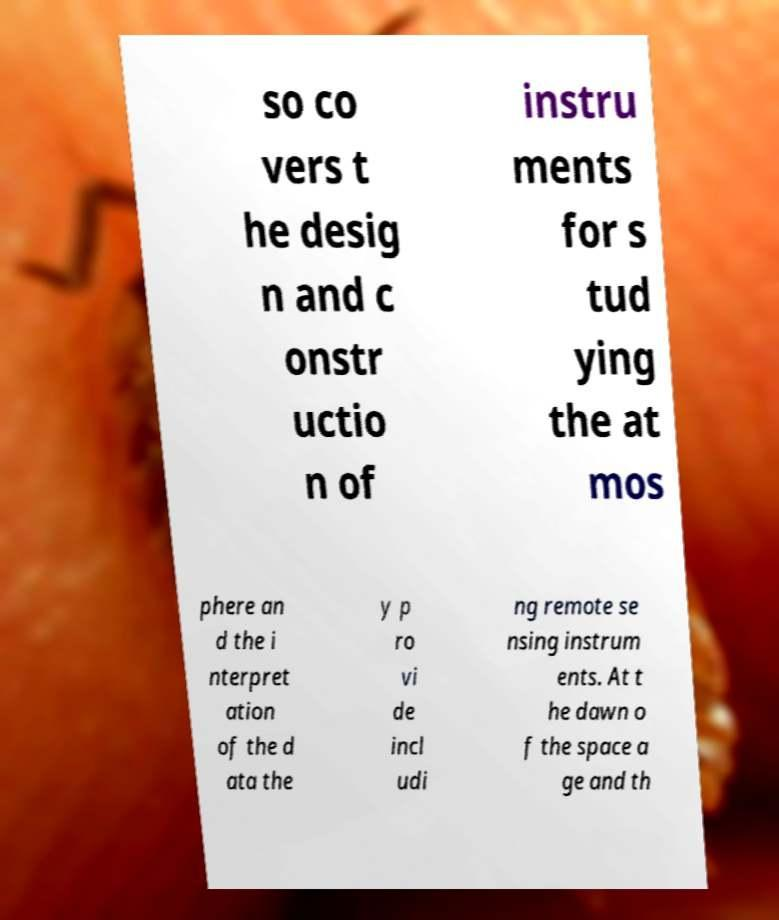What messages or text are displayed in this image? I need them in a readable, typed format. so co vers t he desig n and c onstr uctio n of instru ments for s tud ying the at mos phere an d the i nterpret ation of the d ata the y p ro vi de incl udi ng remote se nsing instrum ents. At t he dawn o f the space a ge and th 